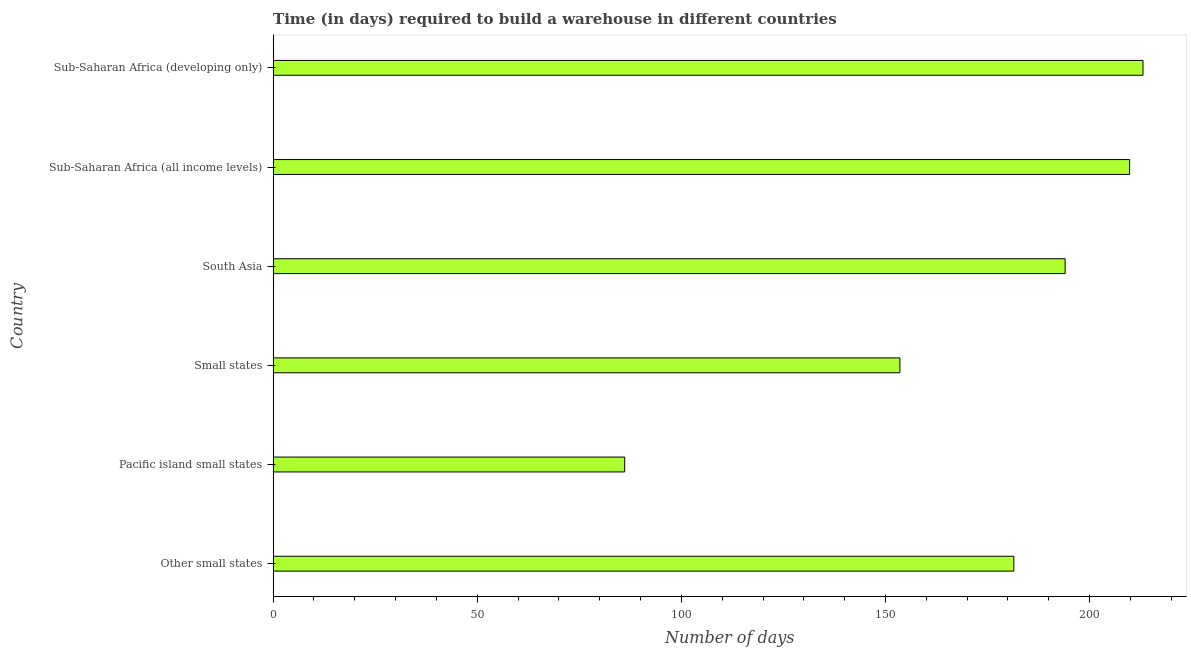Does the graph contain any zero values?
Make the answer very short. No. Does the graph contain grids?
Your answer should be compact. No. What is the title of the graph?
Ensure brevity in your answer.  Time (in days) required to build a warehouse in different countries. What is the label or title of the X-axis?
Offer a terse response. Number of days. What is the label or title of the Y-axis?
Ensure brevity in your answer.  Country. What is the time required to build a warehouse in Sub-Saharan Africa (all income levels)?
Your answer should be compact. 209.8. Across all countries, what is the maximum time required to build a warehouse?
Provide a succinct answer. 213.07. Across all countries, what is the minimum time required to build a warehouse?
Provide a short and direct response. 86.11. In which country was the time required to build a warehouse maximum?
Your answer should be compact. Sub-Saharan Africa (developing only). In which country was the time required to build a warehouse minimum?
Offer a terse response. Pacific island small states. What is the sum of the time required to build a warehouse?
Ensure brevity in your answer.  1037.95. What is the difference between the time required to build a warehouse in Other small states and Sub-Saharan Africa (developing only)?
Your answer should be very brief. -31.63. What is the average time required to build a warehouse per country?
Your answer should be compact. 172.99. What is the median time required to build a warehouse?
Give a very brief answer. 187.72. What is the ratio of the time required to build a warehouse in South Asia to that in Sub-Saharan Africa (all income levels)?
Offer a very short reply. 0.93. Is the time required to build a warehouse in Other small states less than that in Small states?
Keep it short and to the point. No. Is the difference between the time required to build a warehouse in Small states and Sub-Saharan Africa (developing only) greater than the difference between any two countries?
Your answer should be very brief. No. What is the difference between the highest and the second highest time required to build a warehouse?
Offer a very short reply. 3.28. Is the sum of the time required to build a warehouse in Other small states and Sub-Saharan Africa (all income levels) greater than the maximum time required to build a warehouse across all countries?
Provide a short and direct response. Yes. What is the difference between the highest and the lowest time required to build a warehouse?
Provide a succinct answer. 126.96. In how many countries, is the time required to build a warehouse greater than the average time required to build a warehouse taken over all countries?
Your answer should be very brief. 4. How many bars are there?
Offer a very short reply. 6. What is the difference between two consecutive major ticks on the X-axis?
Offer a very short reply. 50. Are the values on the major ticks of X-axis written in scientific E-notation?
Provide a succinct answer. No. What is the Number of days in Other small states?
Provide a short and direct response. 181.44. What is the Number of days in Pacific island small states?
Offer a very short reply. 86.11. What is the Number of days in Small states?
Offer a terse response. 153.53. What is the Number of days of South Asia?
Provide a succinct answer. 194. What is the Number of days in Sub-Saharan Africa (all income levels)?
Keep it short and to the point. 209.8. What is the Number of days of Sub-Saharan Africa (developing only)?
Provide a succinct answer. 213.07. What is the difference between the Number of days in Other small states and Pacific island small states?
Make the answer very short. 95.33. What is the difference between the Number of days in Other small states and Small states?
Provide a succinct answer. 27.92. What is the difference between the Number of days in Other small states and South Asia?
Provide a succinct answer. -12.56. What is the difference between the Number of days in Other small states and Sub-Saharan Africa (all income levels)?
Make the answer very short. -28.35. What is the difference between the Number of days in Other small states and Sub-Saharan Africa (developing only)?
Make the answer very short. -31.63. What is the difference between the Number of days in Pacific island small states and Small states?
Offer a terse response. -67.42. What is the difference between the Number of days in Pacific island small states and South Asia?
Keep it short and to the point. -107.89. What is the difference between the Number of days in Pacific island small states and Sub-Saharan Africa (all income levels)?
Give a very brief answer. -123.68. What is the difference between the Number of days in Pacific island small states and Sub-Saharan Africa (developing only)?
Make the answer very short. -126.96. What is the difference between the Number of days in Small states and South Asia?
Your response must be concise. -40.47. What is the difference between the Number of days in Small states and Sub-Saharan Africa (all income levels)?
Ensure brevity in your answer.  -56.27. What is the difference between the Number of days in Small states and Sub-Saharan Africa (developing only)?
Your answer should be compact. -59.55. What is the difference between the Number of days in South Asia and Sub-Saharan Africa (all income levels)?
Offer a very short reply. -15.8. What is the difference between the Number of days in South Asia and Sub-Saharan Africa (developing only)?
Provide a succinct answer. -19.07. What is the difference between the Number of days in Sub-Saharan Africa (all income levels) and Sub-Saharan Africa (developing only)?
Offer a terse response. -3.28. What is the ratio of the Number of days in Other small states to that in Pacific island small states?
Keep it short and to the point. 2.11. What is the ratio of the Number of days in Other small states to that in Small states?
Provide a succinct answer. 1.18. What is the ratio of the Number of days in Other small states to that in South Asia?
Provide a succinct answer. 0.94. What is the ratio of the Number of days in Other small states to that in Sub-Saharan Africa (all income levels)?
Your answer should be very brief. 0.86. What is the ratio of the Number of days in Other small states to that in Sub-Saharan Africa (developing only)?
Offer a very short reply. 0.85. What is the ratio of the Number of days in Pacific island small states to that in Small states?
Provide a short and direct response. 0.56. What is the ratio of the Number of days in Pacific island small states to that in South Asia?
Offer a very short reply. 0.44. What is the ratio of the Number of days in Pacific island small states to that in Sub-Saharan Africa (all income levels)?
Give a very brief answer. 0.41. What is the ratio of the Number of days in Pacific island small states to that in Sub-Saharan Africa (developing only)?
Your answer should be compact. 0.4. What is the ratio of the Number of days in Small states to that in South Asia?
Offer a terse response. 0.79. What is the ratio of the Number of days in Small states to that in Sub-Saharan Africa (all income levels)?
Your response must be concise. 0.73. What is the ratio of the Number of days in Small states to that in Sub-Saharan Africa (developing only)?
Provide a short and direct response. 0.72. What is the ratio of the Number of days in South Asia to that in Sub-Saharan Africa (all income levels)?
Your response must be concise. 0.93. What is the ratio of the Number of days in South Asia to that in Sub-Saharan Africa (developing only)?
Keep it short and to the point. 0.91. What is the ratio of the Number of days in Sub-Saharan Africa (all income levels) to that in Sub-Saharan Africa (developing only)?
Ensure brevity in your answer.  0.98. 